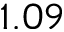<formula> <loc_0><loc_0><loc_500><loc_500>1 . 0 9</formula> 